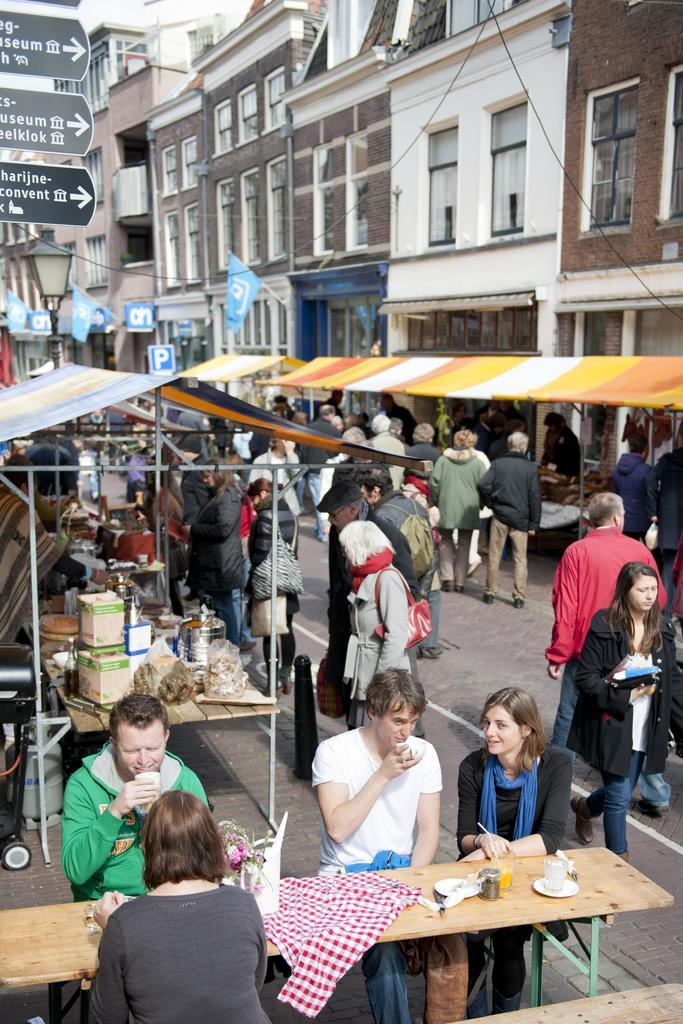What type of structures can be seen in the image? There are buildings in the image. What can be found on the sidewalk in the image? There are stores on the sidewalk in the image. Who is present in the image? There are people standing and people seated on chairs in the image. What is the limit of the brake on the sidewalk in the image? There is no brake present in the image, as it is a scene featuring buildings, stores, and people. How does the throat of the person standing in the image look? The image does not provide enough detail to determine the appearance of the throat of the person standing in the image. 